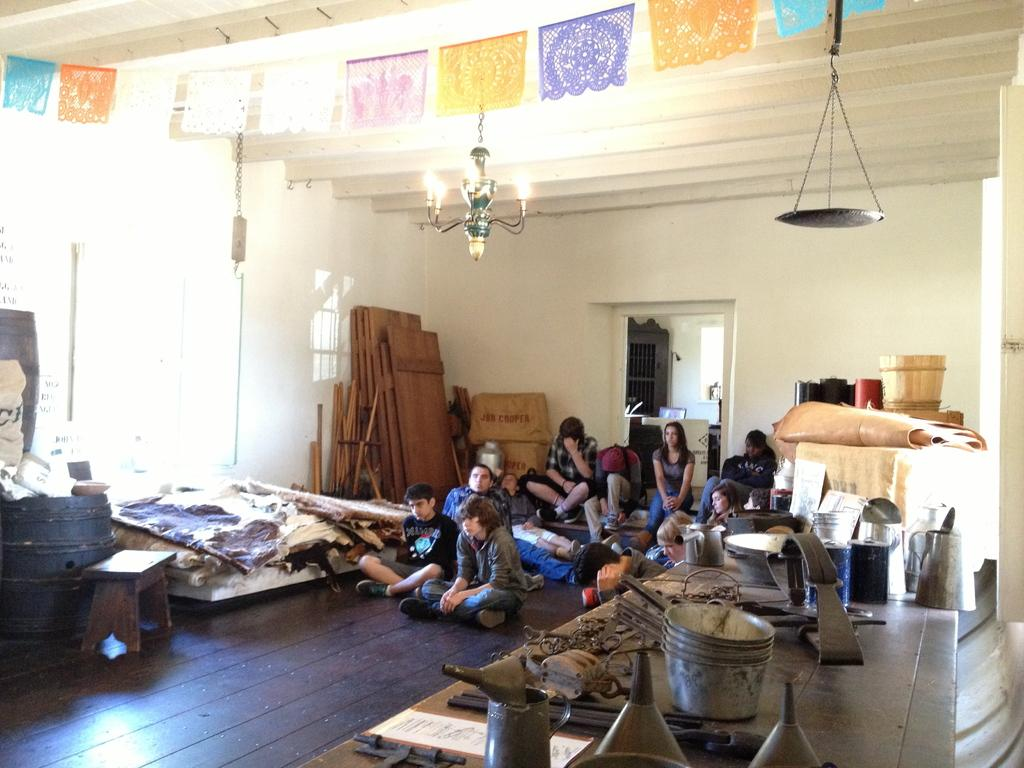What are the people in the image doing? People are sitting in the image. What can be seen above the people? There is decoration and light above the people. What objects are present in the image that might be used for eating or serving food? There are utensils in the image. What type of furniture is visible in the image? There is a bench in the image. What is visible in the background of the image? There is a wall in the background of the image. What type of space suit is the person wearing in the image? There is no person wearing a space suit in the image; people are sitting and there is no reference to space or space suits. 